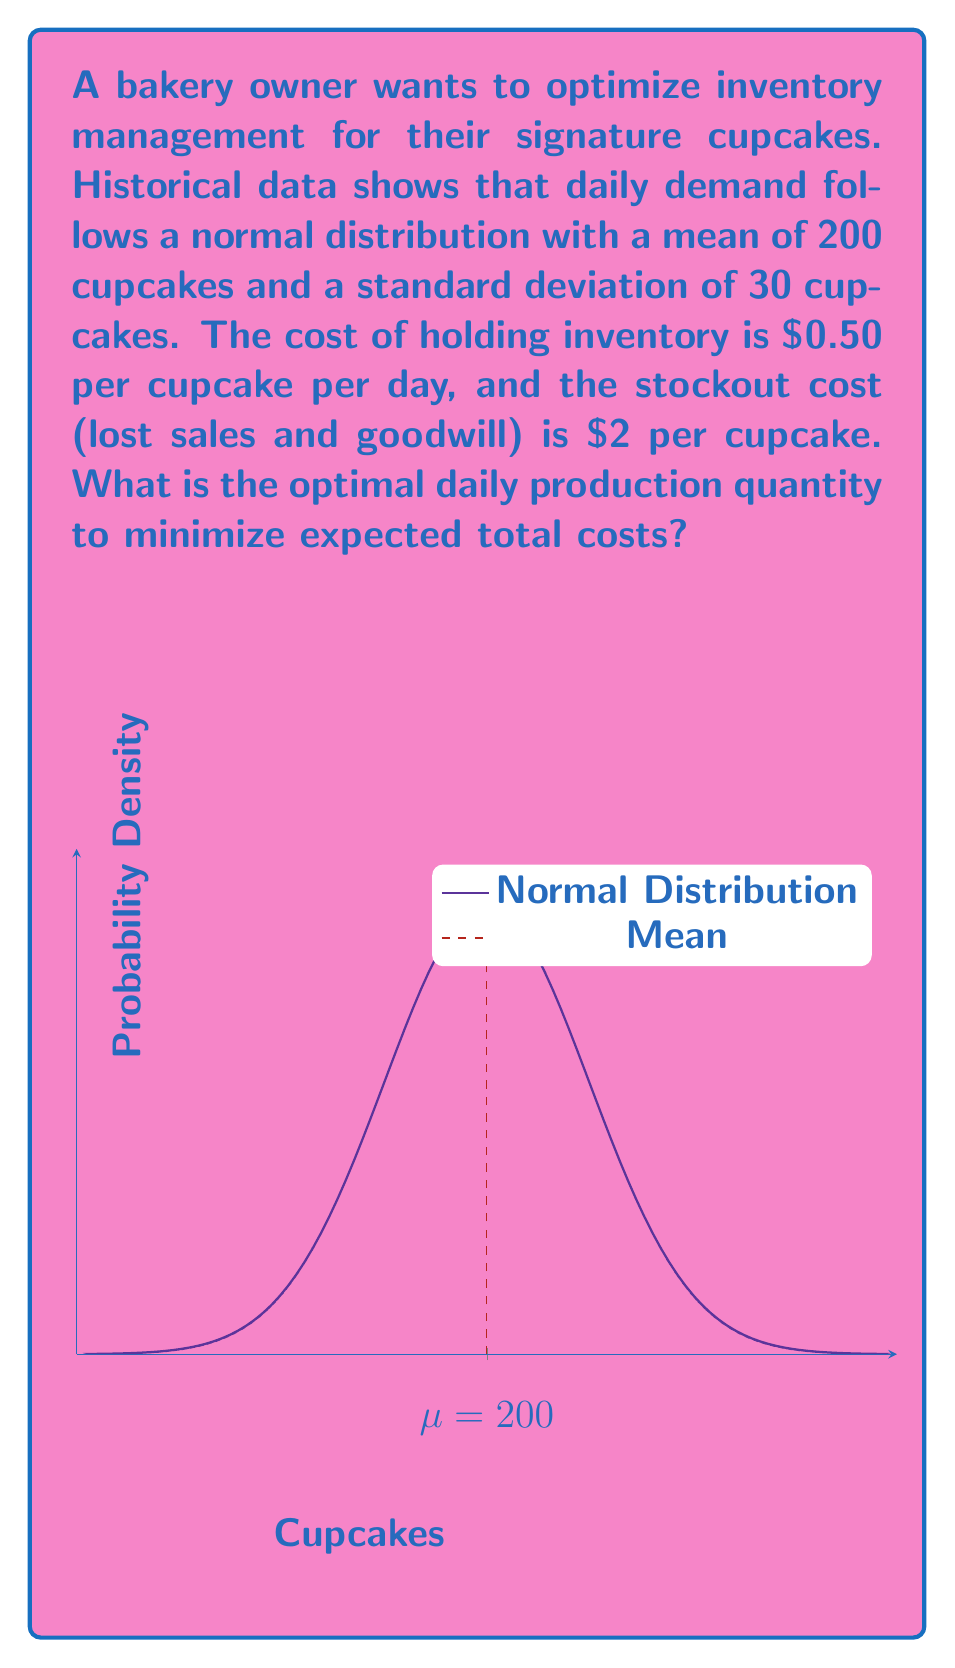Solve this math problem. To solve this problem, we'll use the newsvendor model from inventory management theory. The optimal production quantity Q* is given by the formula:

$$ Q^* = \mu + z\sigma $$

Where:
$\mu$ is the mean demand
$\sigma$ is the standard deviation of demand
$z$ is the z-score corresponding to the critical fractile

The critical fractile is calculated as:

$$ \text{Critical Fractile} = \frac{C_u}{C_u + C_o} $$

Where:
$C_u$ is the underage cost (stockout cost) = $2
$C_o$ is the overage cost (holding cost) = $0.50

Step 1: Calculate the critical fractile
$$ \text{Critical Fractile} = \frac{2}{2 + 0.50} = 0.8 $$

Step 2: Find the z-score corresponding to 0.8
Using a standard normal distribution table or calculator, we find that z ≈ 0.84

Step 3: Calculate the optimal production quantity
$$ Q^* = 200 + 0.84 * 30 = 225.2 $$

Since we can't produce fractional cupcakes, we round to the nearest whole number.
Answer: 225 cupcakes 